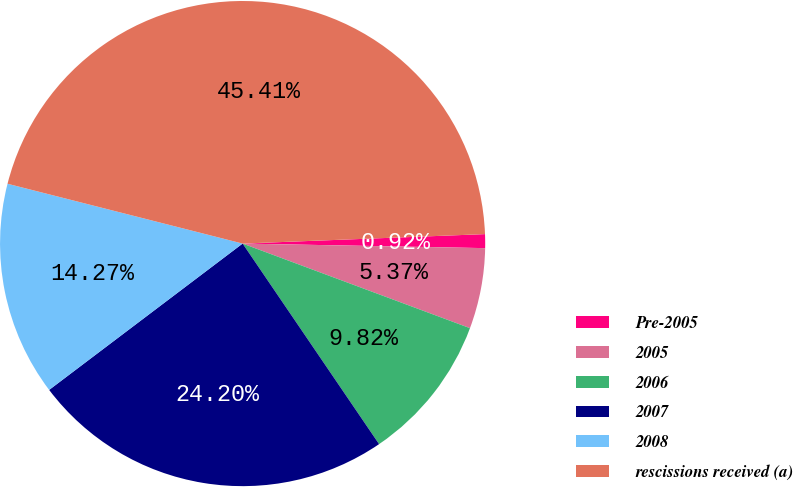Convert chart to OTSL. <chart><loc_0><loc_0><loc_500><loc_500><pie_chart><fcel>Pre-2005<fcel>2005<fcel>2006<fcel>2007<fcel>2008<fcel>rescissions received (a)<nl><fcel>0.92%<fcel>5.37%<fcel>9.82%<fcel>24.2%<fcel>14.27%<fcel>45.41%<nl></chart> 